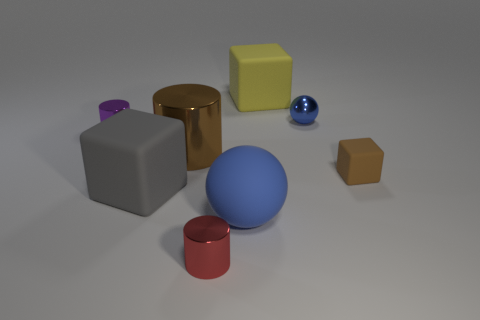Do the cylinder in front of the gray object and the small blue object have the same material?
Make the answer very short. Yes. How many other objects are there of the same color as the tiny matte block?
Your response must be concise. 1. How many other things are there of the same shape as the blue rubber thing?
Give a very brief answer. 1. Does the small thing that is left of the big brown metal thing have the same shape as the small object that is in front of the small block?
Keep it short and to the point. Yes. Are there the same number of big rubber blocks that are behind the large gray block and tiny red metallic things that are to the right of the yellow block?
Your answer should be very brief. No. There is a blue object that is to the left of the shiny thing behind the purple metal object that is in front of the small blue metal sphere; what shape is it?
Provide a succinct answer. Sphere. Are the large block that is to the left of the large metal object and the brown object left of the tiny blue thing made of the same material?
Give a very brief answer. No. There is a large matte thing behind the purple thing; what is its shape?
Give a very brief answer. Cube. Is the number of large rubber spheres less than the number of big matte objects?
Your answer should be compact. Yes. Is there a big rubber thing to the left of the tiny metallic cylinder that is in front of the tiny metallic cylinder behind the big gray cube?
Your answer should be compact. Yes. 